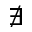Convert formula to latex. <formula><loc_0><loc_0><loc_500><loc_500>\nexists</formula> 